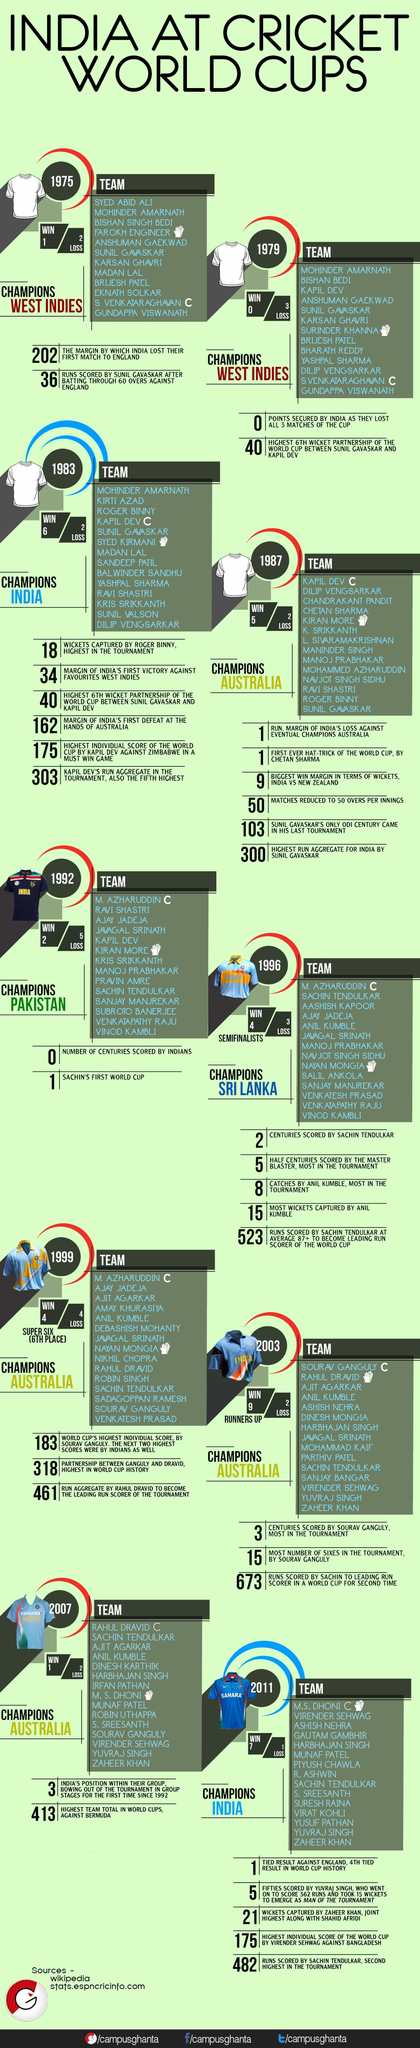In which year did Sri Lanka win the World Cup Championship?
Answer the question with a short phrase. 1996 In which year did India lose all 3 matches of the cup scoring 0 points? 1979 How many times did India win the World Cup Championship? 2 Who won the championship in 2011? India How many times did M. Azharuddin lead the Indian team in the World Cup tournaments? 3 Who was the captain of the Indian team in 1983? Kapil Dev Which team won the World Cup in 1975? West Indies How many times did Australia win the World Cup Championship? 4 How many times has Sachin Tendulkar played in the Indian team for World Cup Tournaments? 6 In which year did Pakistan win the World Cup? 1992 